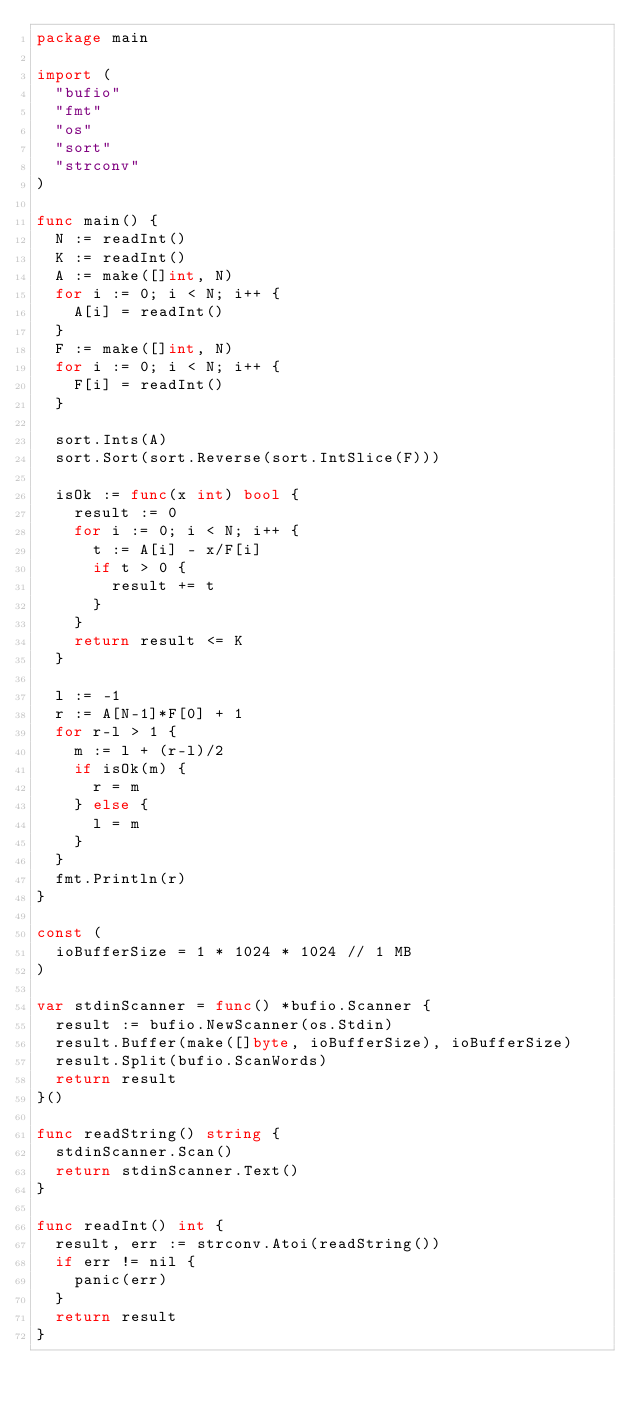<code> <loc_0><loc_0><loc_500><loc_500><_Go_>package main

import (
	"bufio"
	"fmt"
	"os"
	"sort"
	"strconv"
)

func main() {
	N := readInt()
	K := readInt()
	A := make([]int, N)
	for i := 0; i < N; i++ {
		A[i] = readInt()
	}
	F := make([]int, N)
	for i := 0; i < N; i++ {
		F[i] = readInt()
	}

	sort.Ints(A)
	sort.Sort(sort.Reverse(sort.IntSlice(F)))

	isOk := func(x int) bool {
		result := 0
		for i := 0; i < N; i++ {
			t := A[i] - x/F[i]
			if t > 0 {
				result += t
			}
		}
		return result <= K
	}

	l := -1
	r := A[N-1]*F[0] + 1
	for r-l > 1 {
		m := l + (r-l)/2
		if isOk(m) {
			r = m
		} else {
			l = m
		}
	}
	fmt.Println(r)
}

const (
	ioBufferSize = 1 * 1024 * 1024 // 1 MB
)

var stdinScanner = func() *bufio.Scanner {
	result := bufio.NewScanner(os.Stdin)
	result.Buffer(make([]byte, ioBufferSize), ioBufferSize)
	result.Split(bufio.ScanWords)
	return result
}()

func readString() string {
	stdinScanner.Scan()
	return stdinScanner.Text()
}

func readInt() int {
	result, err := strconv.Atoi(readString())
	if err != nil {
		panic(err)
	}
	return result
}
</code> 